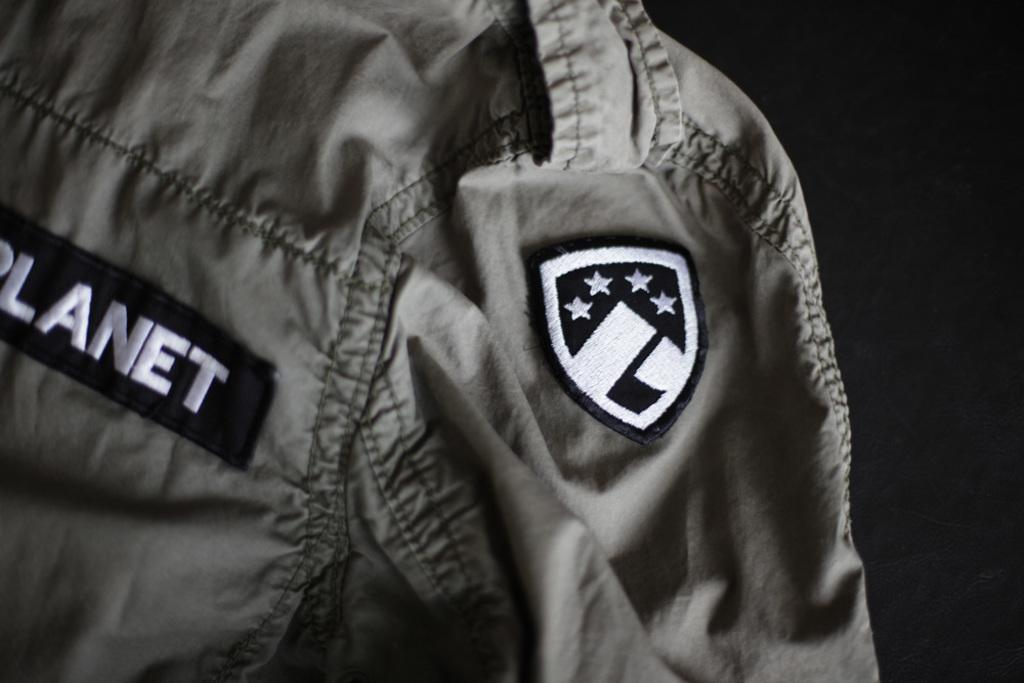<image>
Render a clear and concise summary of the photo. A bomber jacket that has the word planet written on it. 